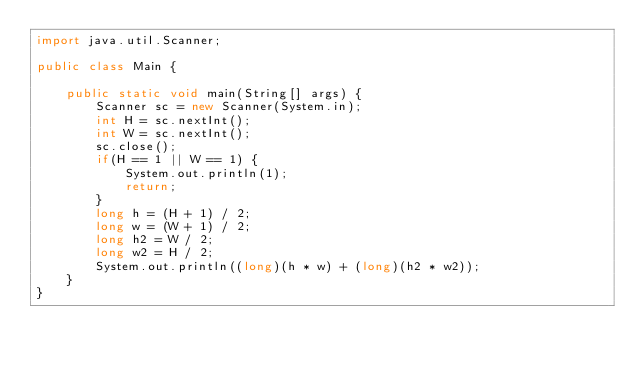<code> <loc_0><loc_0><loc_500><loc_500><_Java_>import java.util.Scanner;

public class Main {

	public static void main(String[] args) {
		Scanner sc = new Scanner(System.in);
		int H = sc.nextInt();
		int W = sc.nextInt();
		sc.close();
		if(H == 1 || W == 1) {
			System.out.println(1);
			return;
		}
		long h = (H + 1) / 2;
		long w = (W + 1) / 2;
		long h2 = W / 2; 
		long w2 = H / 2;
		System.out.println((long)(h * w) + (long)(h2 * w2));
	}
}
</code> 